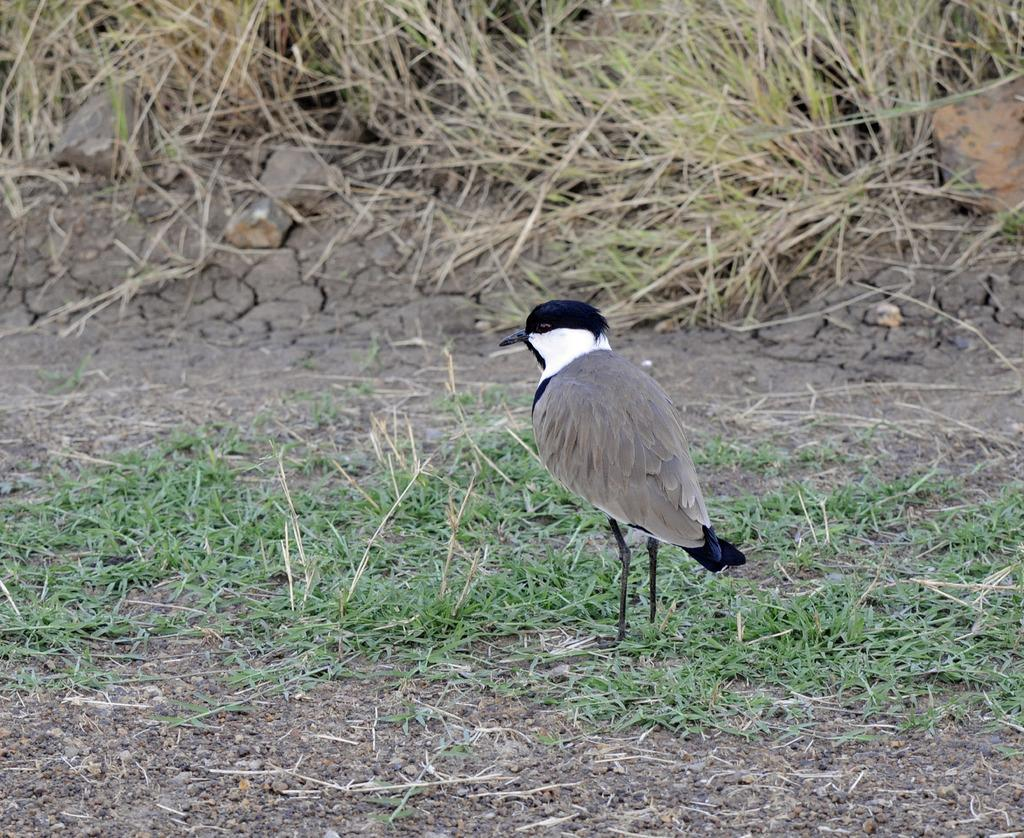What type of animal can be seen in the image? There is a bird in the image. What type of vegetation is at the bottom of the image? There is grass at the bottom of the image. What can be seen in the background of the image? There is dry grass in the background of the image. What type of whistle is being used by the bird in the image? There is no whistle present in the image; it is a bird in a natural setting. 